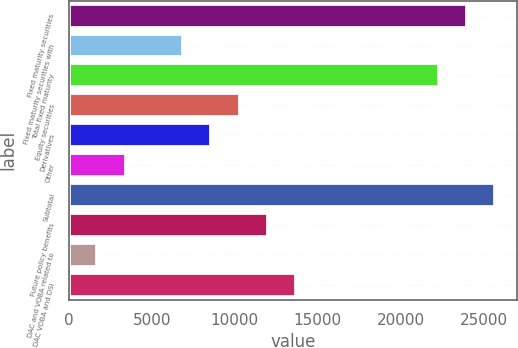Convert chart. <chart><loc_0><loc_0><loc_500><loc_500><bar_chart><fcel>Fixed maturity securities<fcel>Fixed maturity securities with<fcel>Total fixed maturity<fcel>Equity securities<fcel>Derivatives<fcel>Other<fcel>Subtotal<fcel>Future policy benefits<fcel>DAC and VOBA related to<fcel>DAC VOBA and DSI<nl><fcel>24002.8<fcel>6860.8<fcel>22288.6<fcel>10289.2<fcel>8575<fcel>3432.4<fcel>25717<fcel>12003.4<fcel>1718.2<fcel>13717.6<nl></chart> 